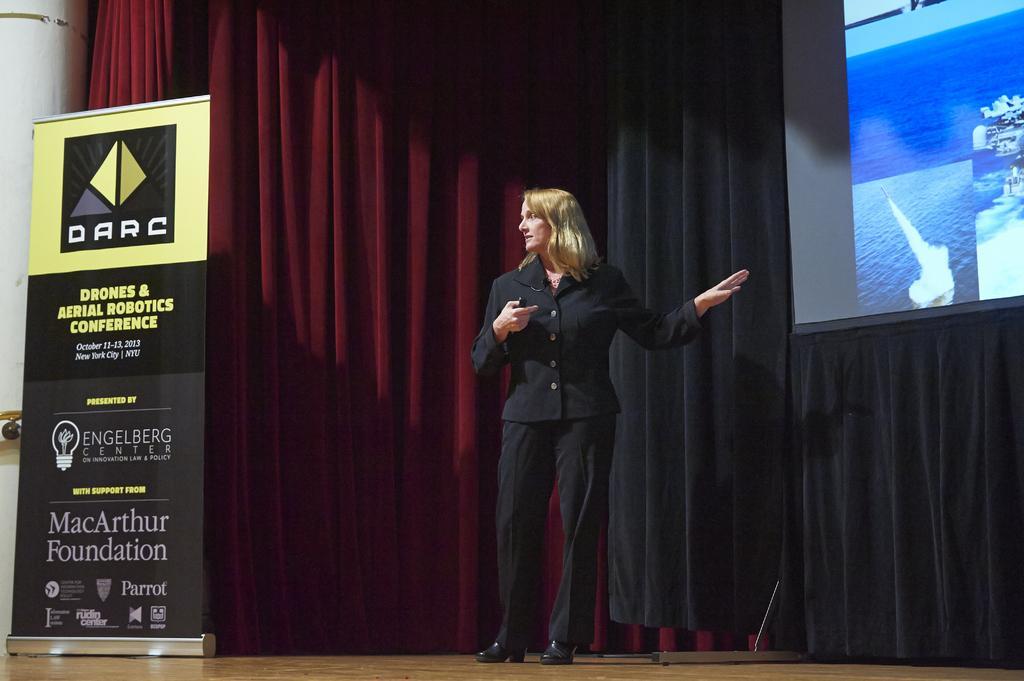Describe this image in one or two sentences. In this image, I can see a woman standing on the floor. On the left side of the image, I can see a banner. On the right side of the image, this is a projector screen. Behind the women there are curtains hanging. 